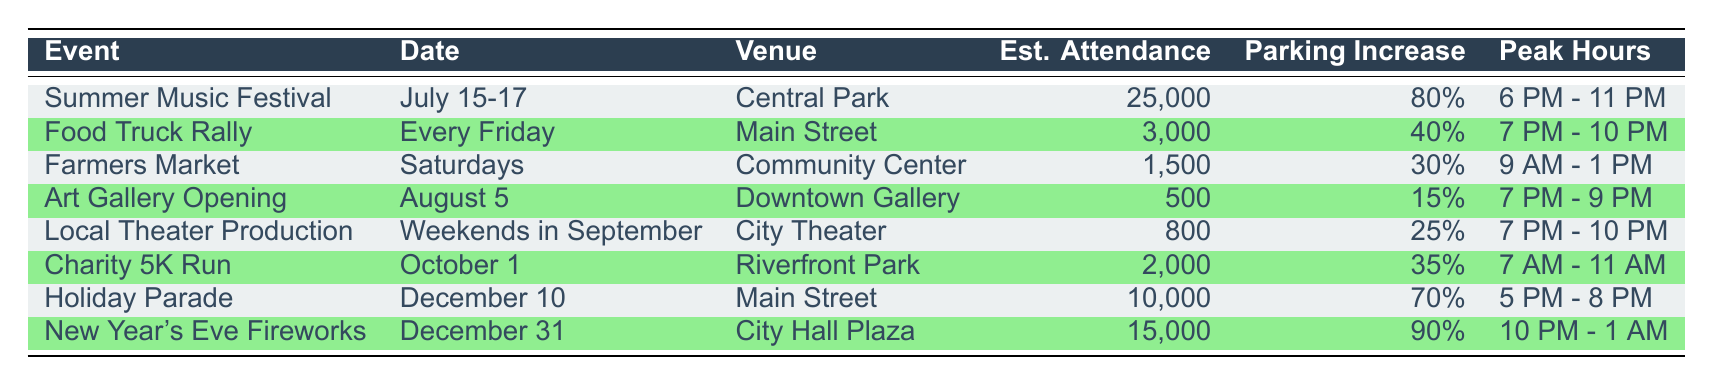What is the estimated attendance for the Summer Music Festival? The table lists the Summer Music Festival under the "Event" column, and it shows an estimated attendance of 25,000 in the "Estimated Attendance" column.
Answer: 25,000 What percentage of parking demand increase is expected for the Holiday Parade? The Holiday Parade is found in the table, which indicates a parking demand increase of 70% in the "Parking Demand Increase" column.
Answer: 70% Which event has the highest estimated attendance? By comparing the "Estimated Attendance" values in the table, the Summer Music Festival has the highest attendance of 25,000, while the other events have lower figures.
Answer: Summer Music Festival What is the average estimated attendance for events happening on Fridays? The only event on Fridays is the Food Truck Rally, with an estimated attendance of 3,000. Since there's only one event, the average is simply 3,000.
Answer: 3,000 Is the parking demand increase for the Farmers Market greater than 30%? The table shows that the Farmers Market has a parking demand increase of 30%. Since the question asks if it is greater, the answer is no.
Answer: No Which event occurs during the peak hours of 7 PM to 10 PM? The Food Truck Rally, Local Theater Production, and Summer Music Festival all occur during these peak hours. By checking the "Peak Hours" column, all three are found in this time range.
Answer: Food Truck Rally, Local Theater Production, Summer Music Festival How many events have an estimated attendance of over 10,000? The events with estimated attendance over 10,000 are the Summer Music Festival (25,000) and New Year's Eve Fireworks (15,000). Adding these gives a total count of 2 events.
Answer: 2 What is the peak hour duration for the Charity 5K Run? The Charity 5K Run has peak hours listed as 7 AM to 11 AM in the "Peak Hours" column.
Answer: 7 AM - 11 AM Does the Art Gallery Opening have a higher attendance than the Local Theater Production? The attendance for the Art Gallery Opening is 500, while the Local Theater Production has 800 attendees. 500 is less than 800, thus the statement is false.
Answer: No What is the total estimated attendance for the events during the weekend (Saturday and Sunday)? The Saturday event is the Farmers Market with 1,500 attendees, and the Local Theater Production occurs on weekends with 800 attendees. The total is calculated as 1,500 + 800 = 2,300.
Answer: 2,300 